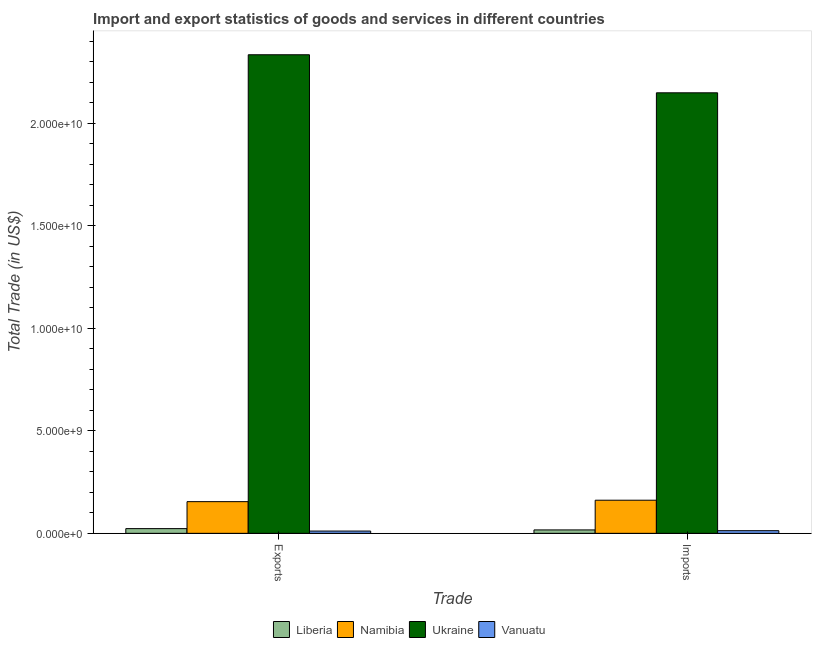How many bars are there on the 1st tick from the left?
Your response must be concise. 4. How many bars are there on the 2nd tick from the right?
Offer a very short reply. 4. What is the label of the 2nd group of bars from the left?
Provide a succinct answer. Imports. What is the imports of goods and services in Ukraine?
Ensure brevity in your answer.  2.15e+1. Across all countries, what is the maximum imports of goods and services?
Keep it short and to the point. 2.15e+1. Across all countries, what is the minimum imports of goods and services?
Make the answer very short. 1.30e+08. In which country was the imports of goods and services maximum?
Offer a terse response. Ukraine. In which country was the export of goods and services minimum?
Provide a succinct answer. Vanuatu. What is the total export of goods and services in the graph?
Your answer should be compact. 2.52e+1. What is the difference between the imports of goods and services in Vanuatu and that in Ukraine?
Ensure brevity in your answer.  -2.14e+1. What is the difference between the imports of goods and services in Ukraine and the export of goods and services in Liberia?
Keep it short and to the point. 2.13e+1. What is the average export of goods and services per country?
Give a very brief answer. 6.31e+09. What is the difference between the export of goods and services and imports of goods and services in Vanuatu?
Keep it short and to the point. -1.86e+07. In how many countries, is the imports of goods and services greater than 2000000000 US$?
Your answer should be compact. 1. What is the ratio of the export of goods and services in Namibia to that in Liberia?
Make the answer very short. 6.72. What does the 4th bar from the left in Exports represents?
Make the answer very short. Vanuatu. What does the 1st bar from the right in Imports represents?
Offer a very short reply. Vanuatu. Are all the bars in the graph horizontal?
Your answer should be very brief. No. How many countries are there in the graph?
Your answer should be very brief. 4. Does the graph contain grids?
Your answer should be very brief. No. Where does the legend appear in the graph?
Provide a succinct answer. Bottom center. What is the title of the graph?
Keep it short and to the point. Import and export statistics of goods and services in different countries. What is the label or title of the X-axis?
Your response must be concise. Trade. What is the label or title of the Y-axis?
Offer a terse response. Total Trade (in US$). What is the Total Trade (in US$) in Liberia in Exports?
Your response must be concise. 2.30e+08. What is the Total Trade (in US$) of Namibia in Exports?
Provide a short and direct response. 1.55e+09. What is the Total Trade (in US$) of Ukraine in Exports?
Provide a short and direct response. 2.34e+1. What is the Total Trade (in US$) in Vanuatu in Exports?
Give a very brief answer. 1.11e+08. What is the Total Trade (in US$) of Liberia in Imports?
Provide a succinct answer. 1.67e+08. What is the Total Trade (in US$) in Namibia in Imports?
Ensure brevity in your answer.  1.62e+09. What is the Total Trade (in US$) of Ukraine in Imports?
Keep it short and to the point. 2.15e+1. What is the Total Trade (in US$) in Vanuatu in Imports?
Provide a succinct answer. 1.30e+08. Across all Trade, what is the maximum Total Trade (in US$) in Liberia?
Provide a succinct answer. 2.30e+08. Across all Trade, what is the maximum Total Trade (in US$) in Namibia?
Offer a terse response. 1.62e+09. Across all Trade, what is the maximum Total Trade (in US$) of Ukraine?
Provide a short and direct response. 2.34e+1. Across all Trade, what is the maximum Total Trade (in US$) in Vanuatu?
Your response must be concise. 1.30e+08. Across all Trade, what is the minimum Total Trade (in US$) in Liberia?
Offer a terse response. 1.67e+08. Across all Trade, what is the minimum Total Trade (in US$) of Namibia?
Offer a terse response. 1.55e+09. Across all Trade, what is the minimum Total Trade (in US$) of Ukraine?
Your answer should be compact. 2.15e+1. Across all Trade, what is the minimum Total Trade (in US$) of Vanuatu?
Ensure brevity in your answer.  1.11e+08. What is the total Total Trade (in US$) of Liberia in the graph?
Your answer should be very brief. 3.97e+08. What is the total Total Trade (in US$) of Namibia in the graph?
Offer a terse response. 3.16e+09. What is the total Total Trade (in US$) of Ukraine in the graph?
Make the answer very short. 4.48e+1. What is the total Total Trade (in US$) of Vanuatu in the graph?
Your answer should be compact. 2.41e+08. What is the difference between the Total Trade (in US$) of Liberia in Exports and that in Imports?
Provide a succinct answer. 6.29e+07. What is the difference between the Total Trade (in US$) of Namibia in Exports and that in Imports?
Keep it short and to the point. -6.96e+07. What is the difference between the Total Trade (in US$) in Ukraine in Exports and that in Imports?
Make the answer very short. 1.86e+09. What is the difference between the Total Trade (in US$) in Vanuatu in Exports and that in Imports?
Provide a succinct answer. -1.86e+07. What is the difference between the Total Trade (in US$) of Liberia in Exports and the Total Trade (in US$) of Namibia in Imports?
Provide a succinct answer. -1.39e+09. What is the difference between the Total Trade (in US$) in Liberia in Exports and the Total Trade (in US$) in Ukraine in Imports?
Offer a very short reply. -2.13e+1. What is the difference between the Total Trade (in US$) of Liberia in Exports and the Total Trade (in US$) of Vanuatu in Imports?
Make the answer very short. 1.00e+08. What is the difference between the Total Trade (in US$) in Namibia in Exports and the Total Trade (in US$) in Ukraine in Imports?
Provide a short and direct response. -1.99e+1. What is the difference between the Total Trade (in US$) in Namibia in Exports and the Total Trade (in US$) in Vanuatu in Imports?
Ensure brevity in your answer.  1.42e+09. What is the difference between the Total Trade (in US$) in Ukraine in Exports and the Total Trade (in US$) in Vanuatu in Imports?
Ensure brevity in your answer.  2.32e+1. What is the average Total Trade (in US$) in Liberia per Trade?
Provide a short and direct response. 1.99e+08. What is the average Total Trade (in US$) in Namibia per Trade?
Offer a very short reply. 1.58e+09. What is the average Total Trade (in US$) in Ukraine per Trade?
Your answer should be compact. 2.24e+1. What is the average Total Trade (in US$) in Vanuatu per Trade?
Provide a succinct answer. 1.20e+08. What is the difference between the Total Trade (in US$) of Liberia and Total Trade (in US$) of Namibia in Exports?
Ensure brevity in your answer.  -1.32e+09. What is the difference between the Total Trade (in US$) of Liberia and Total Trade (in US$) of Ukraine in Exports?
Make the answer very short. -2.31e+1. What is the difference between the Total Trade (in US$) in Liberia and Total Trade (in US$) in Vanuatu in Exports?
Give a very brief answer. 1.19e+08. What is the difference between the Total Trade (in US$) of Namibia and Total Trade (in US$) of Ukraine in Exports?
Offer a terse response. -2.18e+1. What is the difference between the Total Trade (in US$) of Namibia and Total Trade (in US$) of Vanuatu in Exports?
Give a very brief answer. 1.44e+09. What is the difference between the Total Trade (in US$) in Ukraine and Total Trade (in US$) in Vanuatu in Exports?
Give a very brief answer. 2.32e+1. What is the difference between the Total Trade (in US$) in Liberia and Total Trade (in US$) in Namibia in Imports?
Ensure brevity in your answer.  -1.45e+09. What is the difference between the Total Trade (in US$) in Liberia and Total Trade (in US$) in Ukraine in Imports?
Make the answer very short. -2.13e+1. What is the difference between the Total Trade (in US$) of Liberia and Total Trade (in US$) of Vanuatu in Imports?
Ensure brevity in your answer.  3.74e+07. What is the difference between the Total Trade (in US$) in Namibia and Total Trade (in US$) in Ukraine in Imports?
Your answer should be very brief. -1.99e+1. What is the difference between the Total Trade (in US$) in Namibia and Total Trade (in US$) in Vanuatu in Imports?
Offer a terse response. 1.49e+09. What is the difference between the Total Trade (in US$) of Ukraine and Total Trade (in US$) of Vanuatu in Imports?
Ensure brevity in your answer.  2.14e+1. What is the ratio of the Total Trade (in US$) in Liberia in Exports to that in Imports?
Make the answer very short. 1.38. What is the ratio of the Total Trade (in US$) of Namibia in Exports to that in Imports?
Your answer should be very brief. 0.96. What is the ratio of the Total Trade (in US$) of Ukraine in Exports to that in Imports?
Your answer should be compact. 1.09. What is the ratio of the Total Trade (in US$) of Vanuatu in Exports to that in Imports?
Offer a very short reply. 0.86. What is the difference between the highest and the second highest Total Trade (in US$) in Liberia?
Provide a short and direct response. 6.29e+07. What is the difference between the highest and the second highest Total Trade (in US$) of Namibia?
Your answer should be compact. 6.96e+07. What is the difference between the highest and the second highest Total Trade (in US$) in Ukraine?
Give a very brief answer. 1.86e+09. What is the difference between the highest and the second highest Total Trade (in US$) of Vanuatu?
Your answer should be compact. 1.86e+07. What is the difference between the highest and the lowest Total Trade (in US$) of Liberia?
Offer a terse response. 6.29e+07. What is the difference between the highest and the lowest Total Trade (in US$) in Namibia?
Give a very brief answer. 6.96e+07. What is the difference between the highest and the lowest Total Trade (in US$) in Ukraine?
Your answer should be compact. 1.86e+09. What is the difference between the highest and the lowest Total Trade (in US$) in Vanuatu?
Your answer should be very brief. 1.86e+07. 